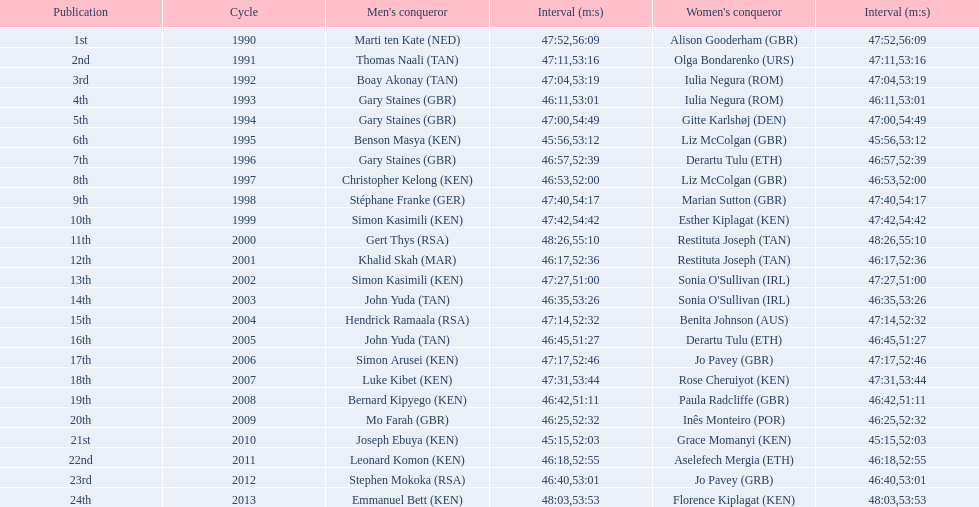What is the name of the first women's winner? Alison Gooderham. 